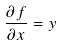Convert formula to latex. <formula><loc_0><loc_0><loc_500><loc_500>\frac { \partial f } { \partial x } = y</formula> 